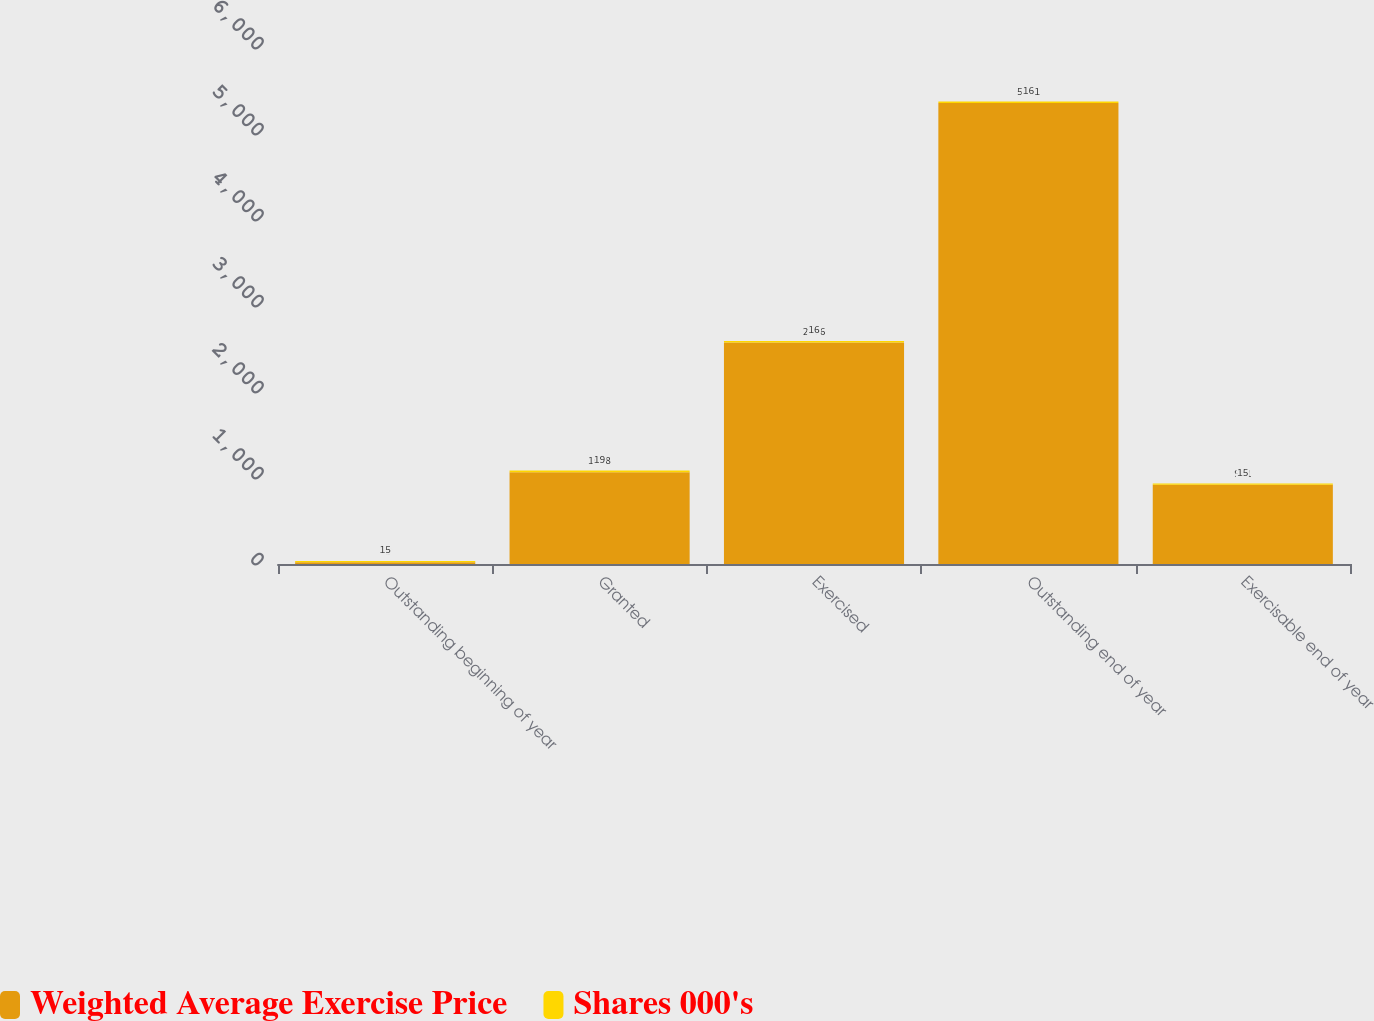Convert chart. <chart><loc_0><loc_0><loc_500><loc_500><stacked_bar_chart><ecel><fcel>Outstanding beginning of year<fcel>Granted<fcel>Exercised<fcel>Outstanding end of year<fcel>Exercisable end of year<nl><fcel>Weighted Average Exercise Price<fcel>19<fcel>1068<fcel>2576<fcel>5361<fcel>921<nl><fcel>Shares 000's<fcel>15<fcel>19<fcel>16<fcel>16<fcel>15<nl></chart> 